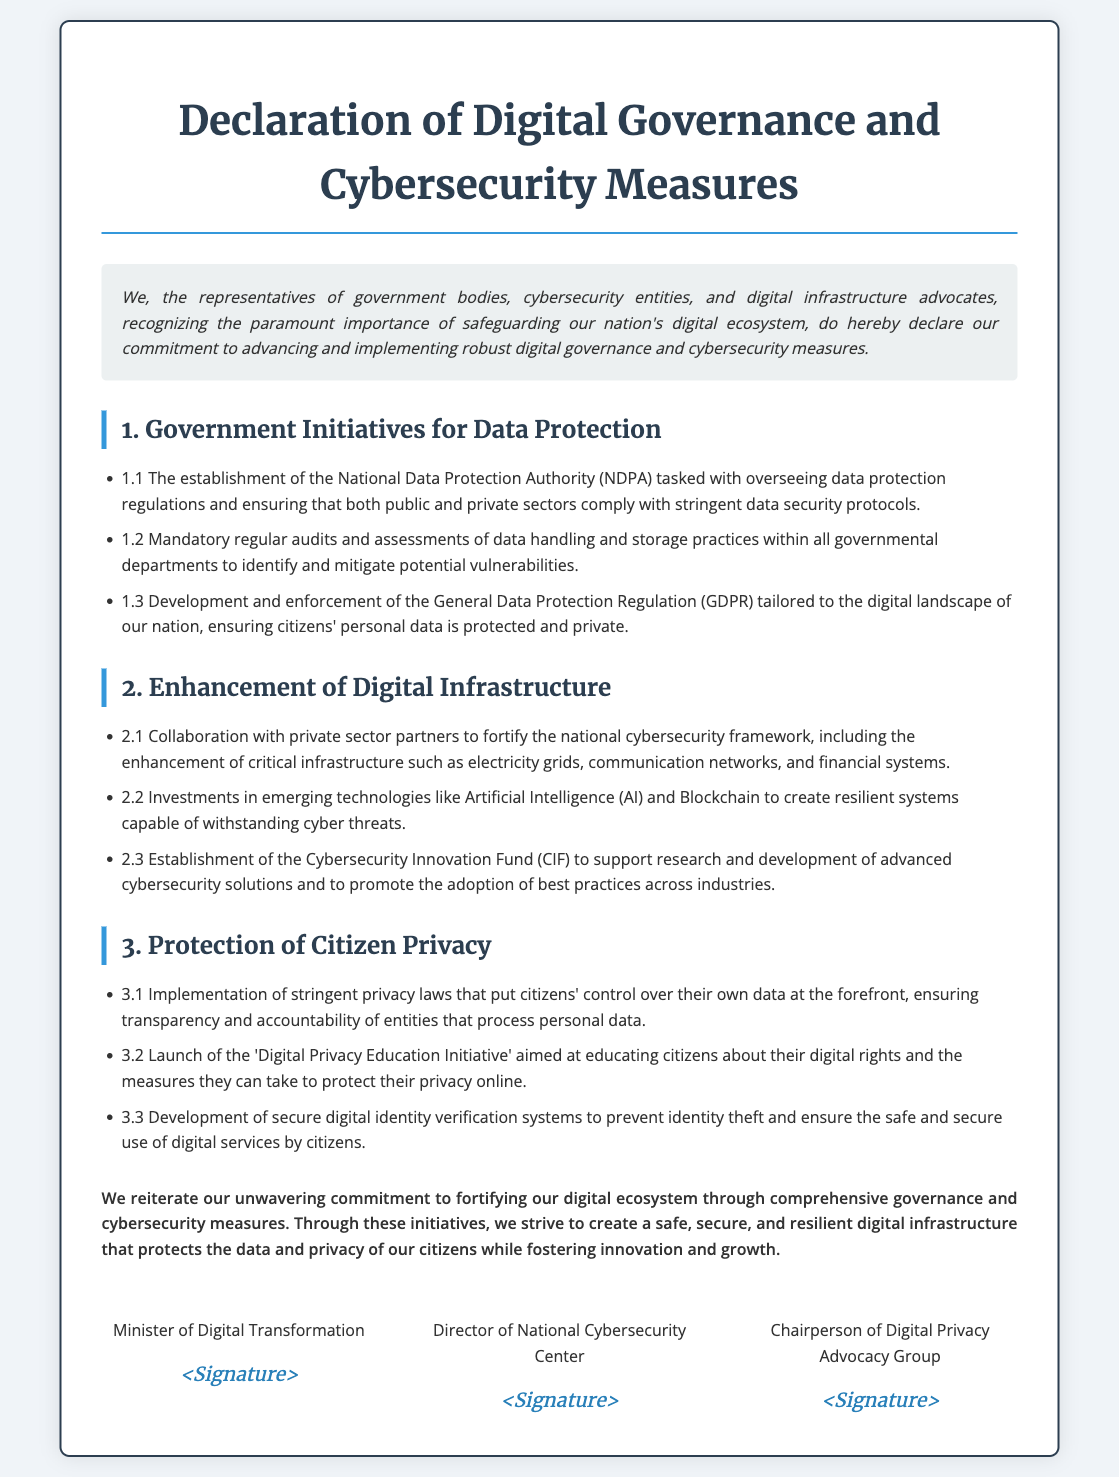What is the title of the document? The title of the document is prominently displayed at the top as the main heading.
Answer: Declaration of Digital Governance and Cybersecurity Measures What is the first initiative for data protection mentioned? The document lists the initiatives in a specific order under the Government Initiatives for Data Protection section.
Answer: The establishment of the National Data Protection Authority What type of fund is established to support cybersecurity solutions? The specific type of fund is mentioned under the Enhancement of Digital Infrastructure section.
Answer: Cybersecurity Innovation Fund Who is one of the signatories of the declaration? The signatures of the officials are listed in the signatories section, providing their titles.
Answer: Minister of Digital Transformation What is the goal of the Digital Privacy Education Initiative? The goal of this initiative is indicated in the context of protecting citizen privacy.
Answer: Educating citizens about their digital rights How many main sections are outlined in the declaration? The document outlines three main sections in the body text, highlighting specific areas of focus.
Answer: Three What does GDPR stand for as referenced in the document? This abbreviation is found in the context of data protection regulations mentioned in the initiatives.
Answer: General Data Protection Regulation What is the concluding sentiment of the declaration? The conclusion summarizes the overall purpose and commitment expressed throughout the document.
Answer: Unwavering commitment to fortifying our digital ecosystem 